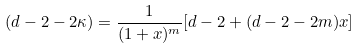Convert formula to latex. <formula><loc_0><loc_0><loc_500><loc_500>( d - 2 - 2 \kappa ) = \frac { 1 } { ( 1 + x ) ^ { m } } [ d - 2 + ( d - 2 - 2 m ) x ]</formula> 